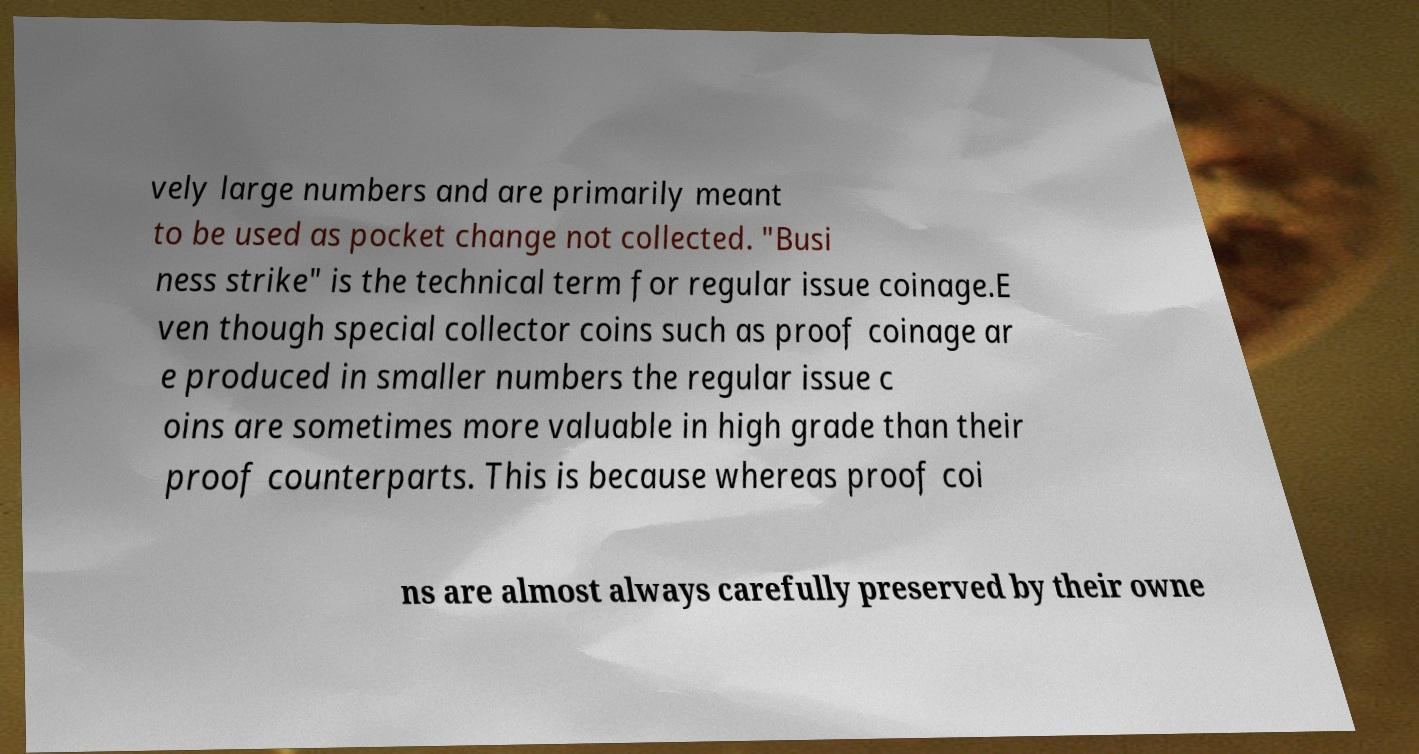Could you assist in decoding the text presented in this image and type it out clearly? vely large numbers and are primarily meant to be used as pocket change not collected. "Busi ness strike" is the technical term for regular issue coinage.E ven though special collector coins such as proof coinage ar e produced in smaller numbers the regular issue c oins are sometimes more valuable in high grade than their proof counterparts. This is because whereas proof coi ns are almost always carefully preserved by their owne 